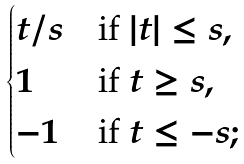Convert formula to latex. <formula><loc_0><loc_0><loc_500><loc_500>\begin{cases} t / s & \text {if $|t|\leq s$} , \\ 1 & \text {if $t\geq s$} , \\ - 1 & \text {if $t\leq -s$} ; \end{cases}</formula> 